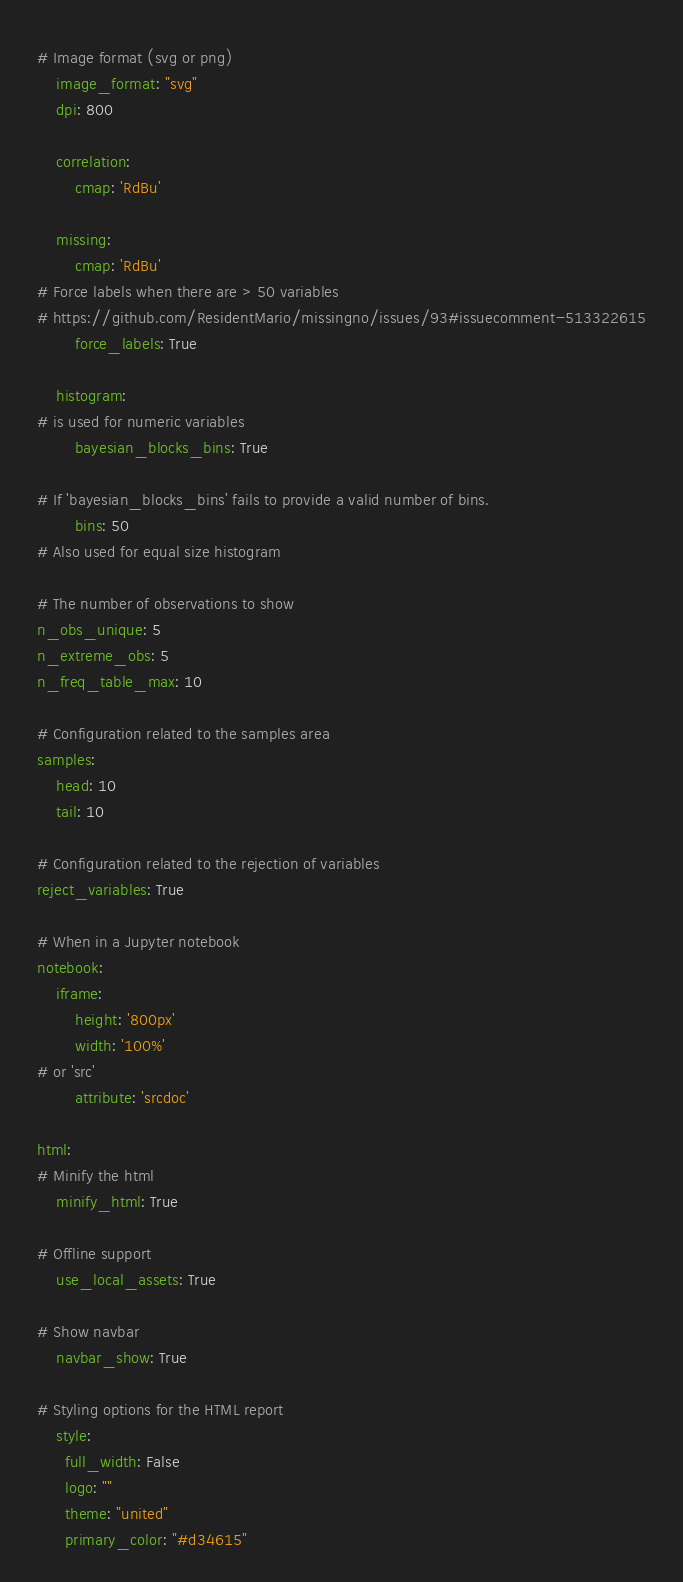<code> <loc_0><loc_0><loc_500><loc_500><_YAML_># Image format (svg or png)
    image_format: "svg"
    dpi: 800

    correlation:
        cmap: 'RdBu'

    missing:
        cmap: 'RdBu'
# Force labels when there are > 50 variables
# https://github.com/ResidentMario/missingno/issues/93#issuecomment-513322615
        force_labels: True

    histogram:
# is used for numeric variables
        bayesian_blocks_bins: True

# If 'bayesian_blocks_bins' fails to provide a valid number of bins.
        bins: 50
# Also used for equal size histogram

# The number of observations to show
n_obs_unique: 5
n_extreme_obs: 5
n_freq_table_max: 10

# Configuration related to the samples area
samples:
    head: 10
    tail: 10

# Configuration related to the rejection of variables
reject_variables: True

# When in a Jupyter notebook
notebook:
    iframe:
        height: '800px'
        width: '100%'
# or 'src'
        attribute: 'srcdoc'

html:
# Minify the html
    minify_html: True

# Offline support
    use_local_assets: True

# Show navbar
    navbar_show: True

# Styling options for the HTML report
    style:
      full_width: False
      logo: ""
      theme: "united"
      primary_color: "#d34615"
</code> 